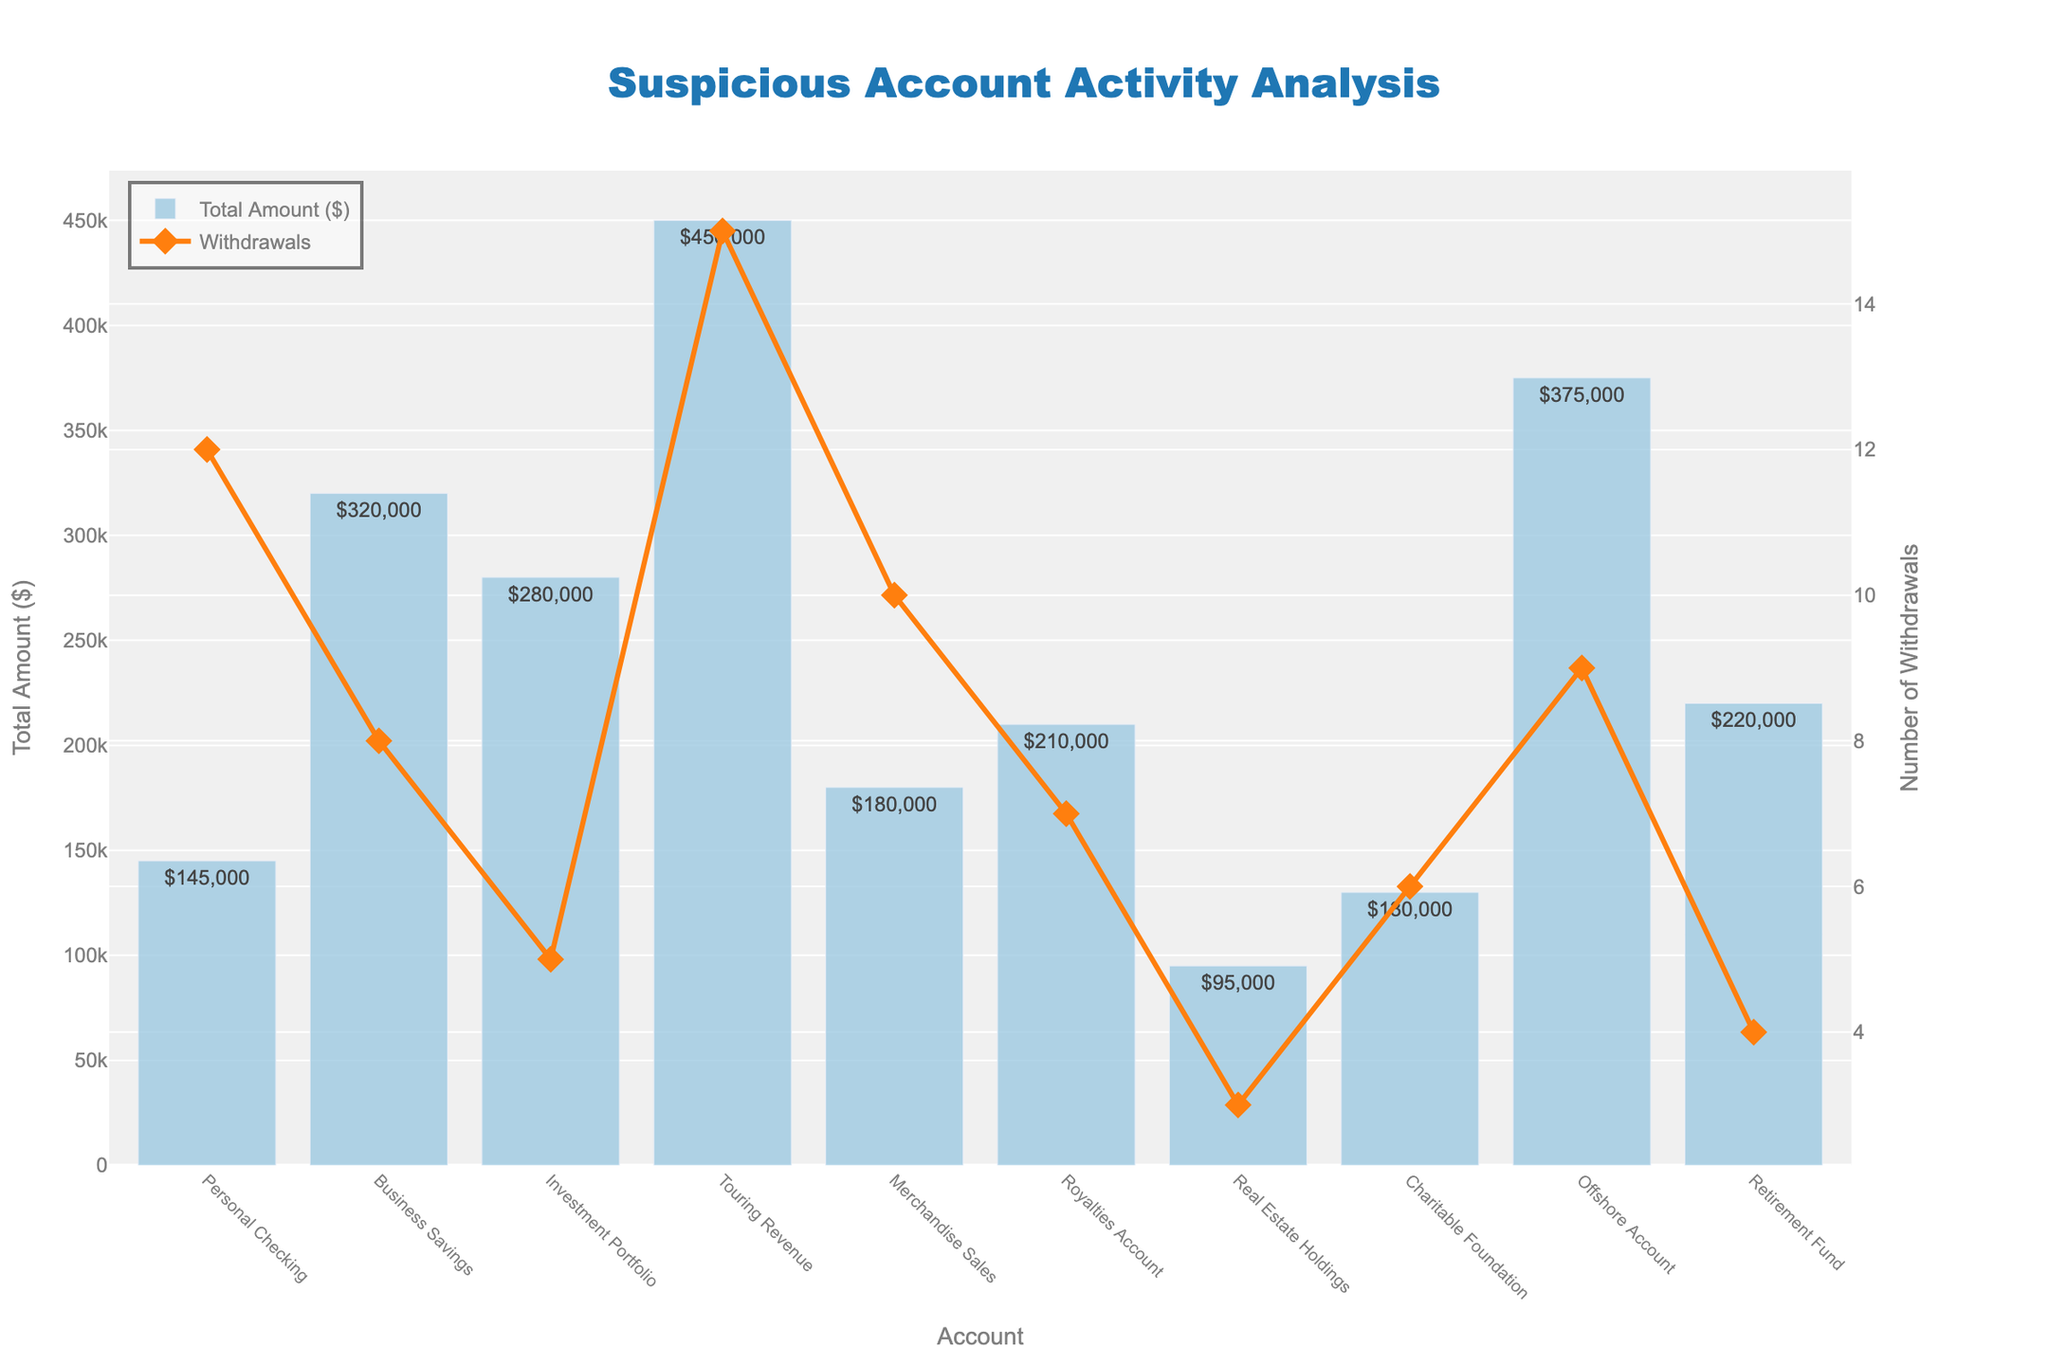Which account has the highest number of withdrawals? The account with the highest number of withdrawals has the tallest line point on the withdrawal series. Looking at the plot, the "Touring Revenue" account has the highest number of withdrawals at 15.
Answer: Touring Revenue Which two accounts have similar total amounts withdrawn, and what are those amounts? Look at the height of the bars and find two bars with similar heights. The "Royalties Account" and "Retirement Fund" accounts both have total amounts around $210,000 - $220,000.
Answer: Royalties Account ($210,000) and Retirement Fund ($220,000) What is the combined total amount of unexplained cash withdrawals from the "Personal Checking" and "Merchandise Sales" accounts? Add the total amounts for these accounts: $145,000 (Personal Checking) + $180,000 (Merchandise Sales) = $325,000.
Answer: $325,000 Which account had fewer withdrawals but more total amount withdrawn than the "Personal Checking" account? Look for an account with fewer than 12 withdrawals but more than $145,000 in total amount. The "Investment Portfolio" account has 5 withdrawals and a total amount of $280,000, which fits these criteria.
Answer: Investment Portfolio How many accounts have more than 200,000 in total amount of unexplained cash withdrawals? Count the number of bars that extend above the $200,000 mark. The accounts are "Business Savings," "Investment Portfolio," "Touring Revenue," "Offshore Account," and "Retirement Fund." This gives us 5 accounts.
Answer: 5 accounts What is the ratio of withdrawals for the "Touring Revenue" account to the "Charitable Foundation" account? Divide the number of withdrawals in "Touring Revenue" (15) by those in "Charitable Foundation" (6): 15/6 ≈ 2.5.
Answer: 2.5 Which account shows the largest discrepancy between the number of withdrawals and the total amount withdrawn? Look for a significant visual gap between the lines and bars. The "Offshore Account" has 9 withdrawals with a very high total amount of $375,000, indicating a large discrepancy.
Answer: Offshore Account How much more was withdrawn from the "Offshore Account" compared to the "Business Savings" account? Subtract the total amount of "Business Savings" ($320,000) from the "Offshore Account" ($375,000): $375,000 - $320,000 = $55,000.
Answer: $55,000 What's the average number of withdrawals per account? Sum the number of withdrawals across all accounts and divide by the number of accounts: (12+8+5+15+10+7+3+6+9+4)/10 = 79/10 = 7.9
Answer: 7.9 Which account has the lowest total amount of unexplained cash withdrawals? Identify the shortest bar in the plot. The "Real Estate Holdings" account has the lowest total amount at $95,000.
Answer: Real Estate Holdings 